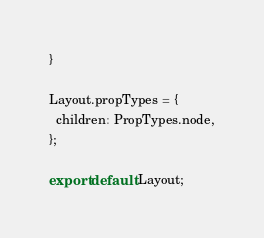Convert code to text. <code><loc_0><loc_0><loc_500><loc_500><_JavaScript_>}

Layout.propTypes = {
  children: PropTypes.node,
};

export default Layout;
</code> 